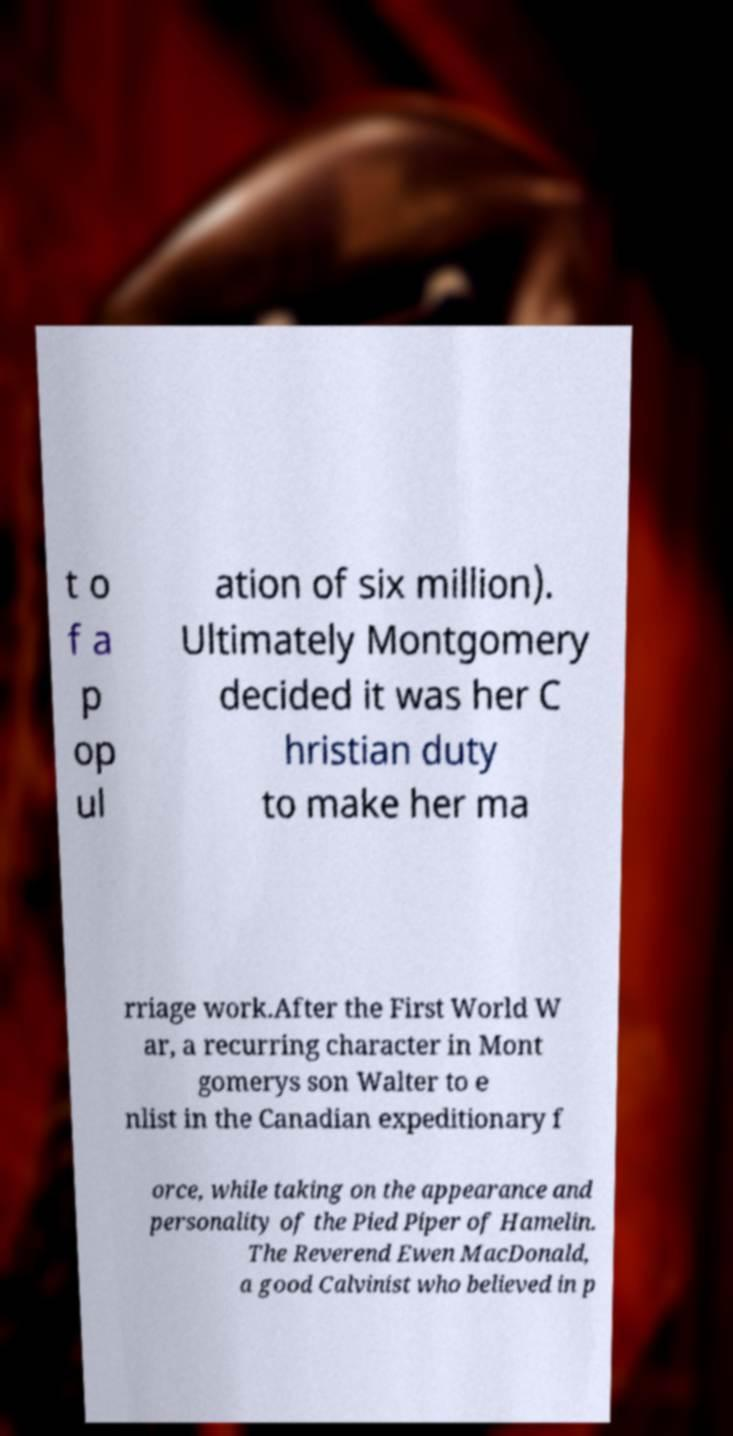Please identify and transcribe the text found in this image. t o f a p op ul ation of six million). Ultimately Montgomery decided it was her C hristian duty to make her ma rriage work.After the First World W ar, a recurring character in Mont gomerys son Walter to e nlist in the Canadian expeditionary f orce, while taking on the appearance and personality of the Pied Piper of Hamelin. The Reverend Ewen MacDonald, a good Calvinist who believed in p 